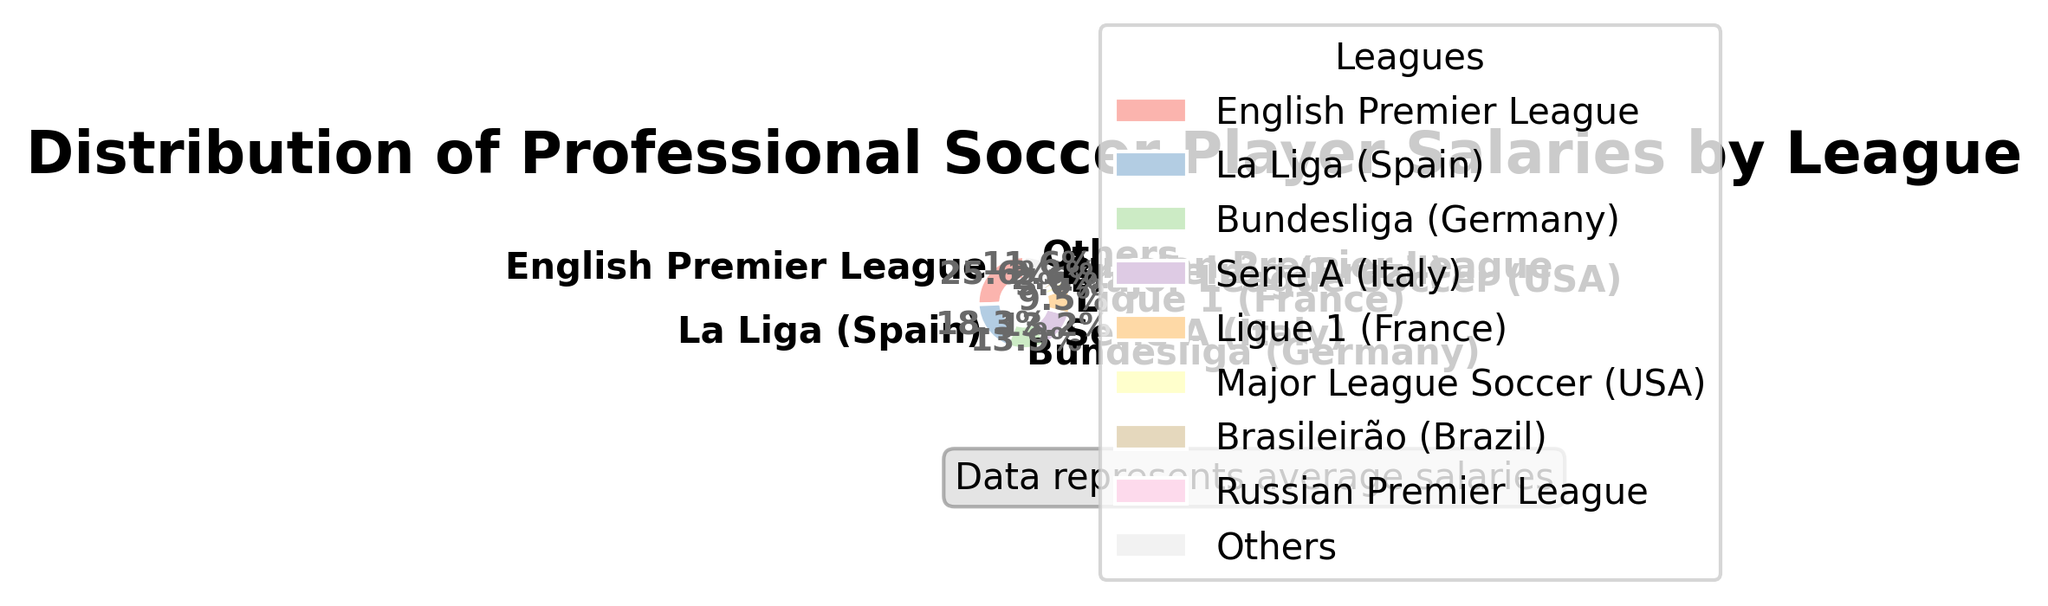Which league has the highest average salary? The English Premier League has the highest average salary, and it accounts for the largest segment in the pie chart.
Answer: English Premier League What's the combined percentage of the top two leagues? The top two leagues are the English Premier League and La Liga (Spain). The English Premier League accounts for 39.7% and La Liga for 28.3%, adding up to 39.7% + 28.3% = 68%.
Answer: 68% Which league has a smaller percentage than the 'Others' category? The 'Others' category accounts for a specific percentage labeled on the pie chart. The Major League Soccer, Brasileirão, Russian Premier League, Chinese Super League, Eredivisie, Scottish Premiership, J1 League, Liga MX, A-League, and K League 1 all have smaller segments than 'Others'.
Answer: Major League Soccer (USA), Brasileirão (Brazil), Russian Premier League, Chinese Super League, Eredivisie (Netherlands), Scottish Premiership, J1 League (Japan), Liga MX (Mexico), A-League (Australia), and K League 1 (South Korea) What is the total percentage covered by the top five leagues? The top five leagues are the English Premier League, La Liga (Spain), Bundesliga (Germany), Serie A (Italy), and Ligue 1 (France), with percentages 39.7%, 28.3%, 21.5%, 5.8%, and 4.9% respectively. Summing these up: 39.7% + 28.3% + 21.5% + 5.8% + 4.9% = 100.2%.
Answer: 100.2% Compared to Ligue 1, by what margin does the English Premier League have a higher salary distribution percentage? The English Premier League has 39.7% while Ligue 1 has 4.9%. The difference is 39.7% - 4.9% = 34.8%.
Answer: 34.8% What is the visual significance of the colors used in the pie chart? Different colors represent different leagues. The various pastel shades help distinguish between the league segments visually, with the 'Others' category often being distinctly colored to summarize the smaller segments.
Answer: Different colors represent different leagues Which two leagues combined are roughly equal in percentage to Bundesliga alone? Serie A (Italy) has 5.8% and Ligue 1 (France) has 4.9%. Together, they amount to 5.8% + 4.9% = 10.7%, which roughly matches Bundesliga's 21.5% when summed up with MLS 4.6% which is near twice.
Answer: Serie A (Italy) and Ligue 1 (France) What’s the difference between the lowest and the highest percentage segments in the chart? The difference is between the English Premier League (39.7%) and K League 1 (1.9% in Others), so the difference is 39.7% - 1.9% = 37.8%.
Answer: 37.8% Explain why the 'Others' category is used in the pie chart. The 'Others' category groups together leagues with small individual percentages to simplify the chart and improve readability, ensuring the chart does not become cluttered with too many small segments.
Answer: To simplify the chart and avoid clutter What does the percentage of Major League Soccer suggest about its average salary relative to other leagues? With Major League Soccer representing a smaller percentage of the pie (4.1%), it indicates that its average salary is lower compared to the top leagues like the English Premier League and La Liga.
Answer: Lower than top leagues 